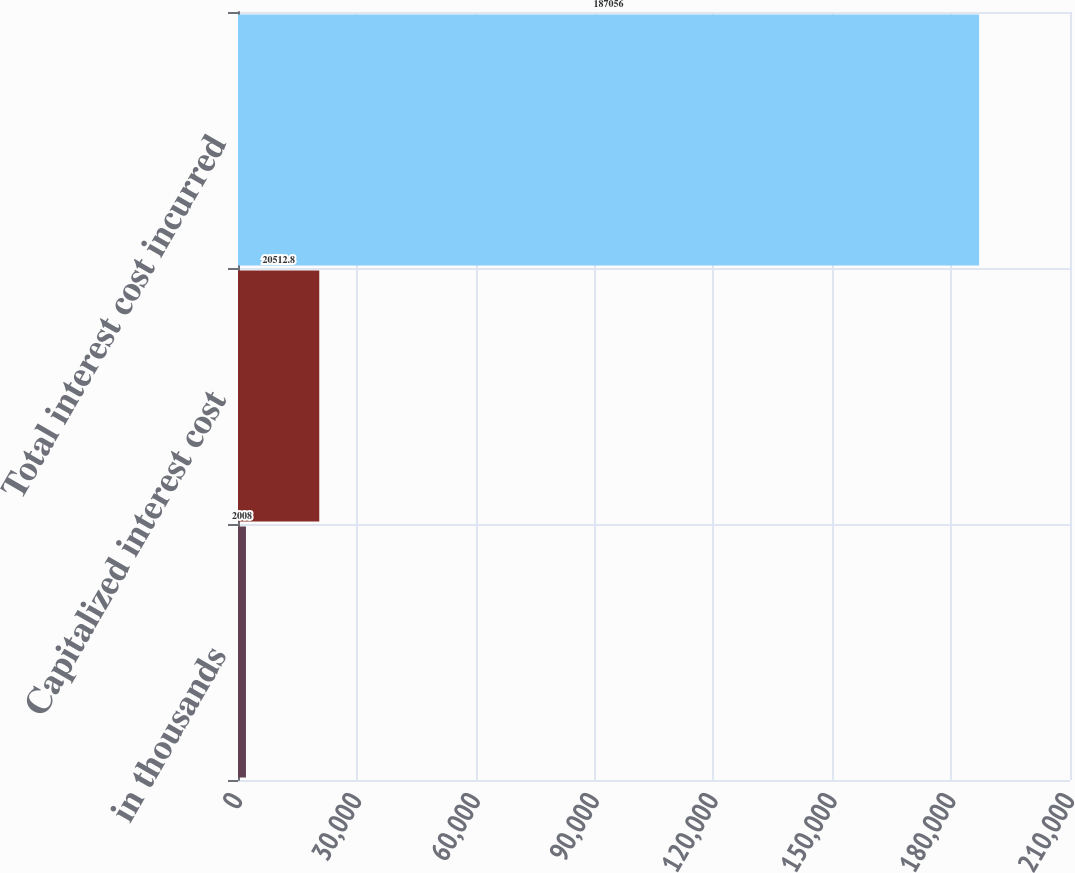Convert chart to OTSL. <chart><loc_0><loc_0><loc_500><loc_500><bar_chart><fcel>in thousands<fcel>Capitalized interest cost<fcel>Total interest cost incurred<nl><fcel>2008<fcel>20512.8<fcel>187056<nl></chart> 